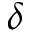<formula> <loc_0><loc_0><loc_500><loc_500>\delta</formula> 